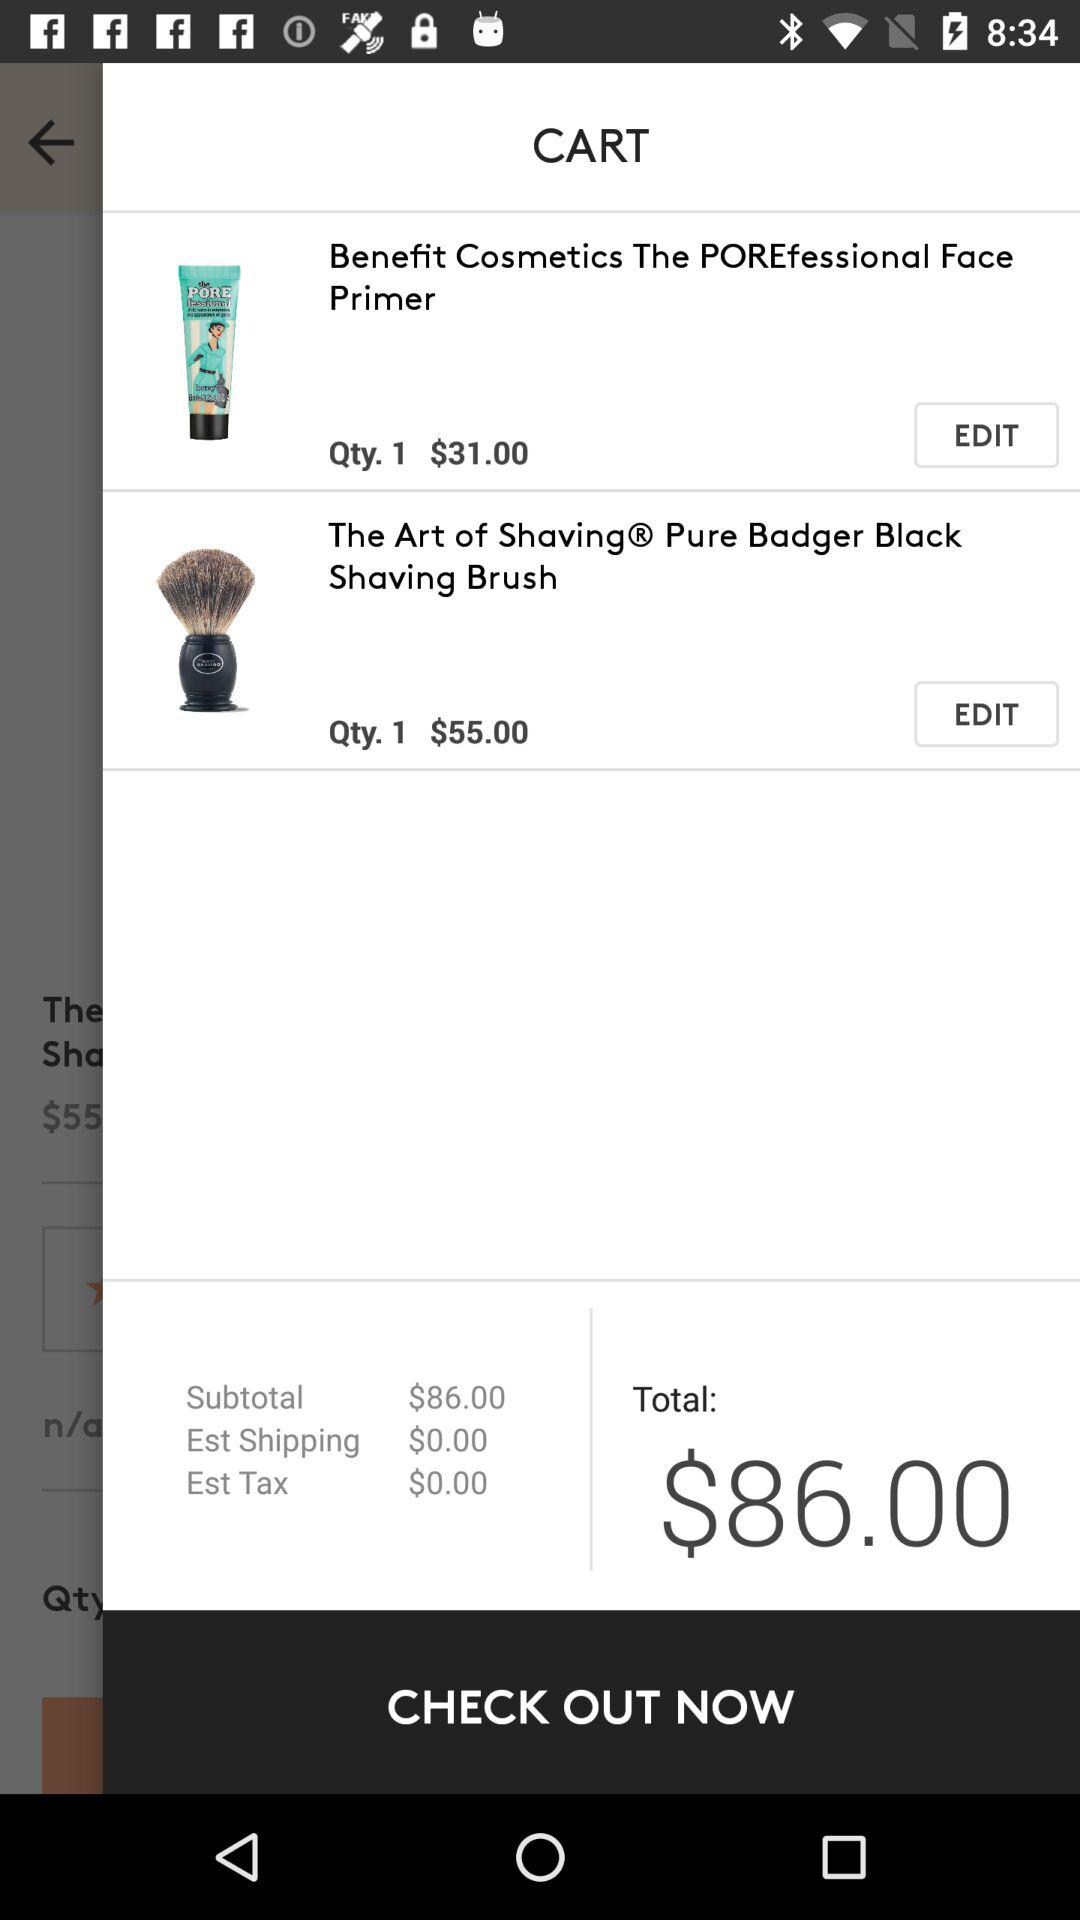What is the price of "Benefit Cosmetics The POREfessional Face Primer"? The price of "Benefit Cosmetics The POREfessional Face Primer" is $31. 